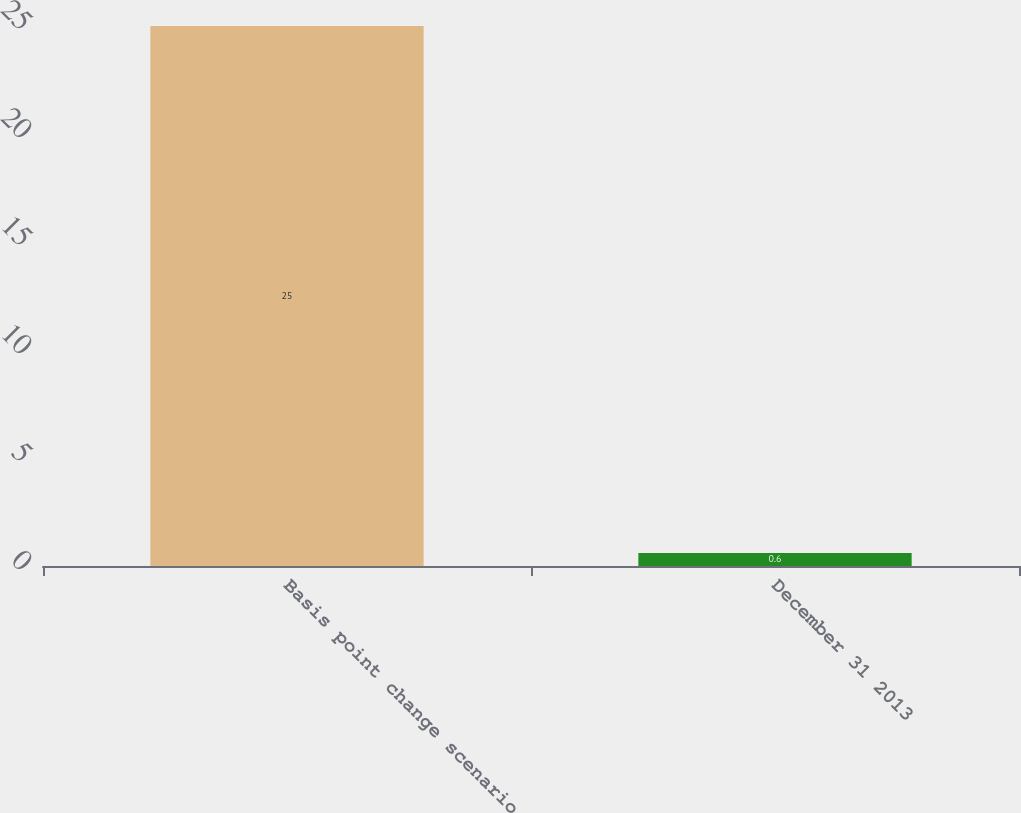Convert chart. <chart><loc_0><loc_0><loc_500><loc_500><bar_chart><fcel>Basis point change scenario<fcel>December 31 2013<nl><fcel>25<fcel>0.6<nl></chart> 